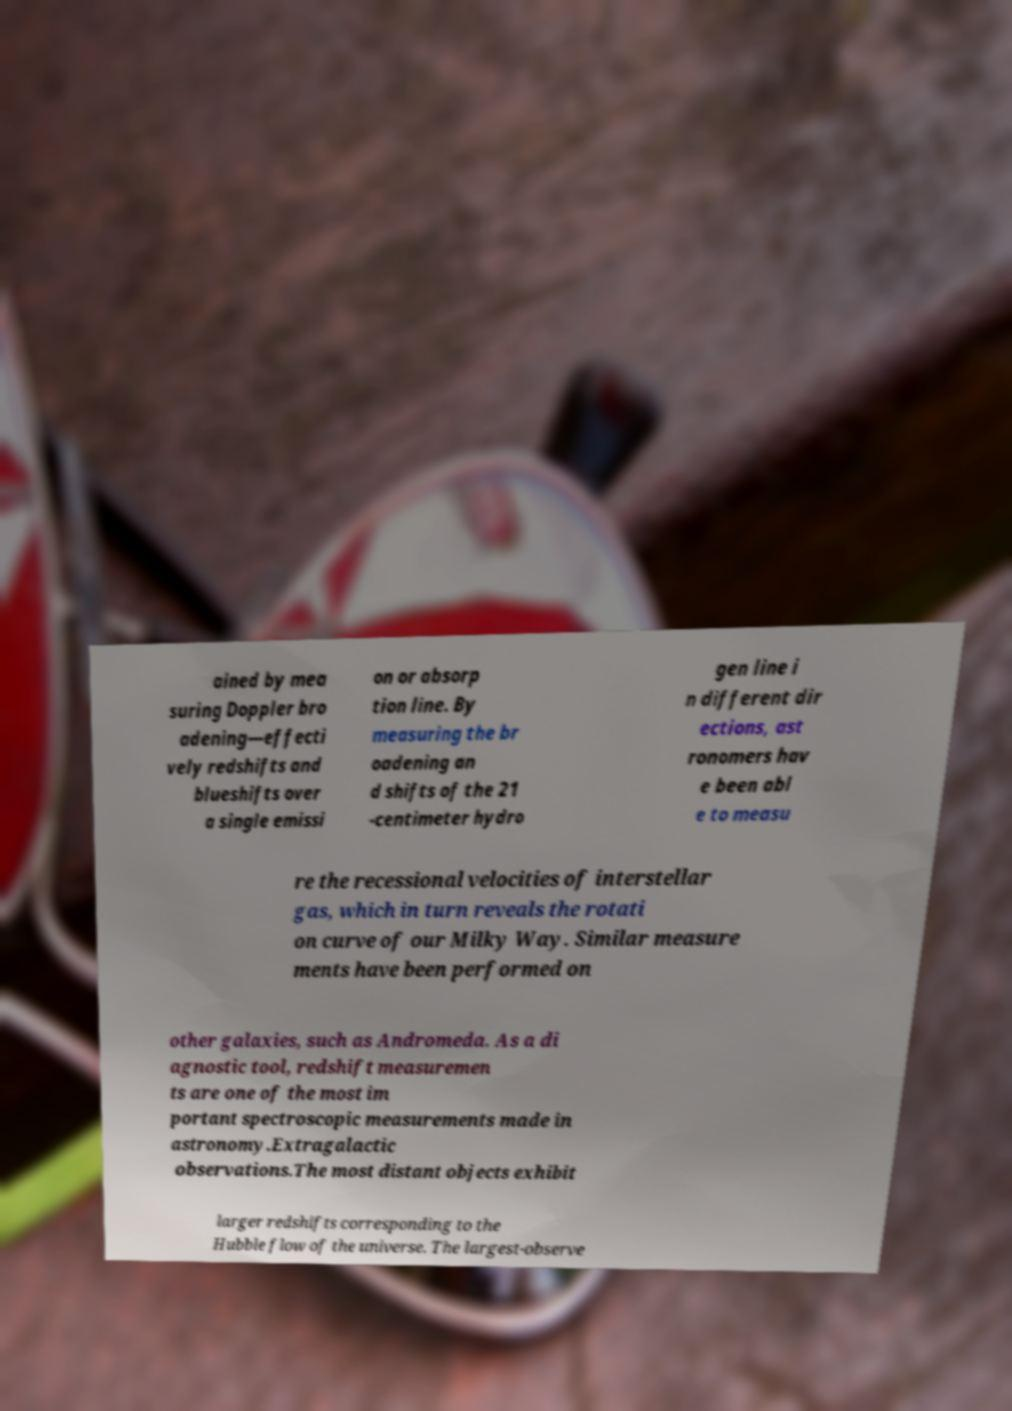Please read and relay the text visible in this image. What does it say? ained by mea suring Doppler bro adening—effecti vely redshifts and blueshifts over a single emissi on or absorp tion line. By measuring the br oadening an d shifts of the 21 -centimeter hydro gen line i n different dir ections, ast ronomers hav e been abl e to measu re the recessional velocities of interstellar gas, which in turn reveals the rotati on curve of our Milky Way. Similar measure ments have been performed on other galaxies, such as Andromeda. As a di agnostic tool, redshift measuremen ts are one of the most im portant spectroscopic measurements made in astronomy.Extragalactic observations.The most distant objects exhibit larger redshifts corresponding to the Hubble flow of the universe. The largest-observe 